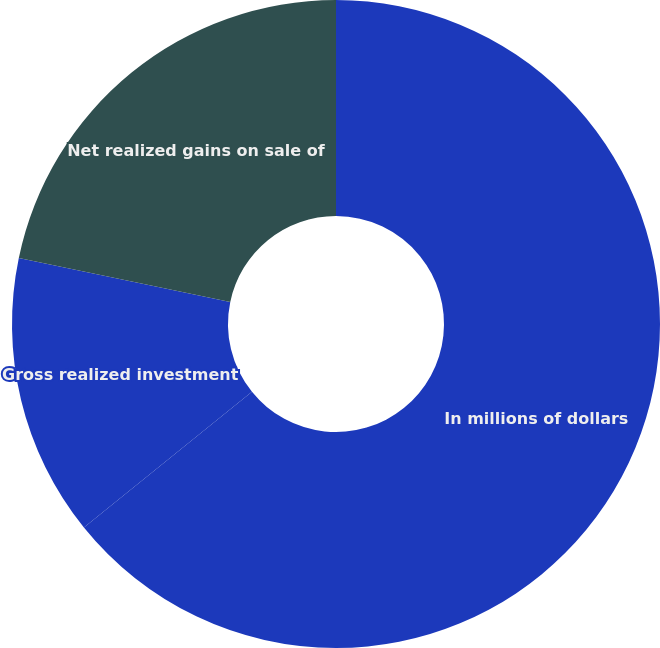Convert chart. <chart><loc_0><loc_0><loc_500><loc_500><pie_chart><fcel>In millions of dollars<fcel>Gross realized investment<fcel>Net realized gains on sale of<nl><fcel>64.19%<fcel>14.08%<fcel>21.73%<nl></chart> 